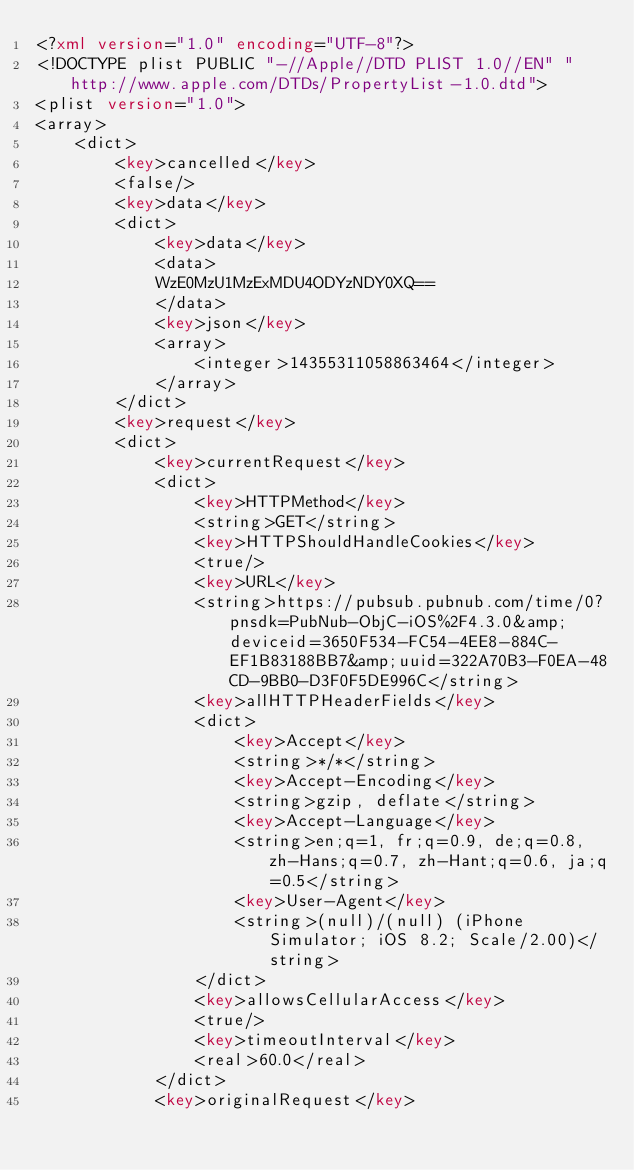<code> <loc_0><loc_0><loc_500><loc_500><_XML_><?xml version="1.0" encoding="UTF-8"?>
<!DOCTYPE plist PUBLIC "-//Apple//DTD PLIST 1.0//EN" "http://www.apple.com/DTDs/PropertyList-1.0.dtd">
<plist version="1.0">
<array>
	<dict>
		<key>cancelled</key>
		<false/>
		<key>data</key>
		<dict>
			<key>data</key>
			<data>
			WzE0MzU1MzExMDU4ODYzNDY0XQ==
			</data>
			<key>json</key>
			<array>
				<integer>14355311058863464</integer>
			</array>
		</dict>
		<key>request</key>
		<dict>
			<key>currentRequest</key>
			<dict>
				<key>HTTPMethod</key>
				<string>GET</string>
				<key>HTTPShouldHandleCookies</key>
				<true/>
				<key>URL</key>
				<string>https://pubsub.pubnub.com/time/0?pnsdk=PubNub-ObjC-iOS%2F4.3.0&amp;deviceid=3650F534-FC54-4EE8-884C-EF1B83188BB7&amp;uuid=322A70B3-F0EA-48CD-9BB0-D3F0F5DE996C</string>
				<key>allHTTPHeaderFields</key>
				<dict>
					<key>Accept</key>
					<string>*/*</string>
					<key>Accept-Encoding</key>
					<string>gzip, deflate</string>
					<key>Accept-Language</key>
					<string>en;q=1, fr;q=0.9, de;q=0.8, zh-Hans;q=0.7, zh-Hant;q=0.6, ja;q=0.5</string>
					<key>User-Agent</key>
					<string>(null)/(null) (iPhone Simulator; iOS 8.2; Scale/2.00)</string>
				</dict>
				<key>allowsCellularAccess</key>
				<true/>
				<key>timeoutInterval</key>
				<real>60.0</real>
			</dict>
			<key>originalRequest</key></code> 